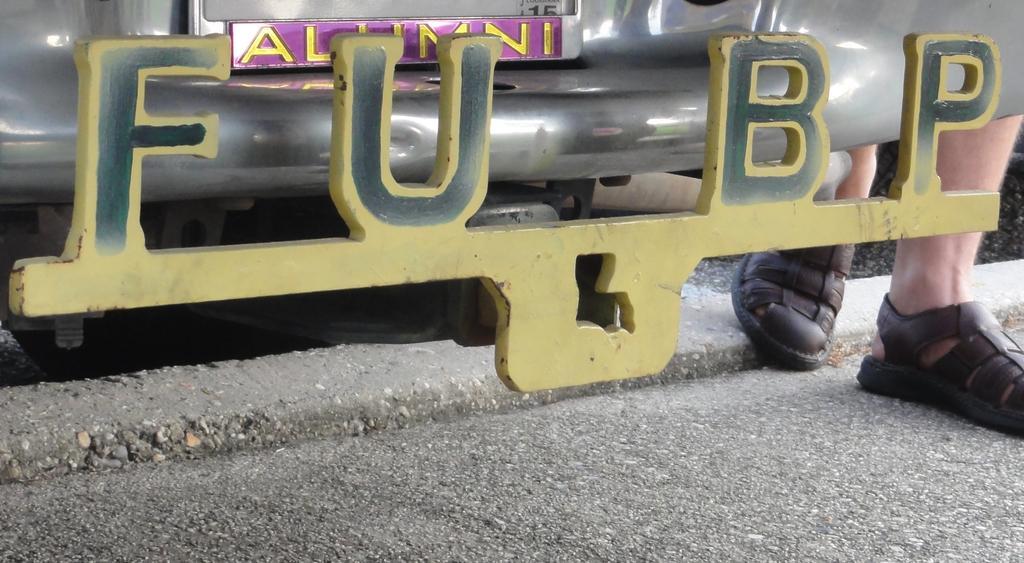How would you summarize this image in a sentence or two? There is a number plate of a car as we can see at the top of this image, and there are human legs on the right side of this image. 